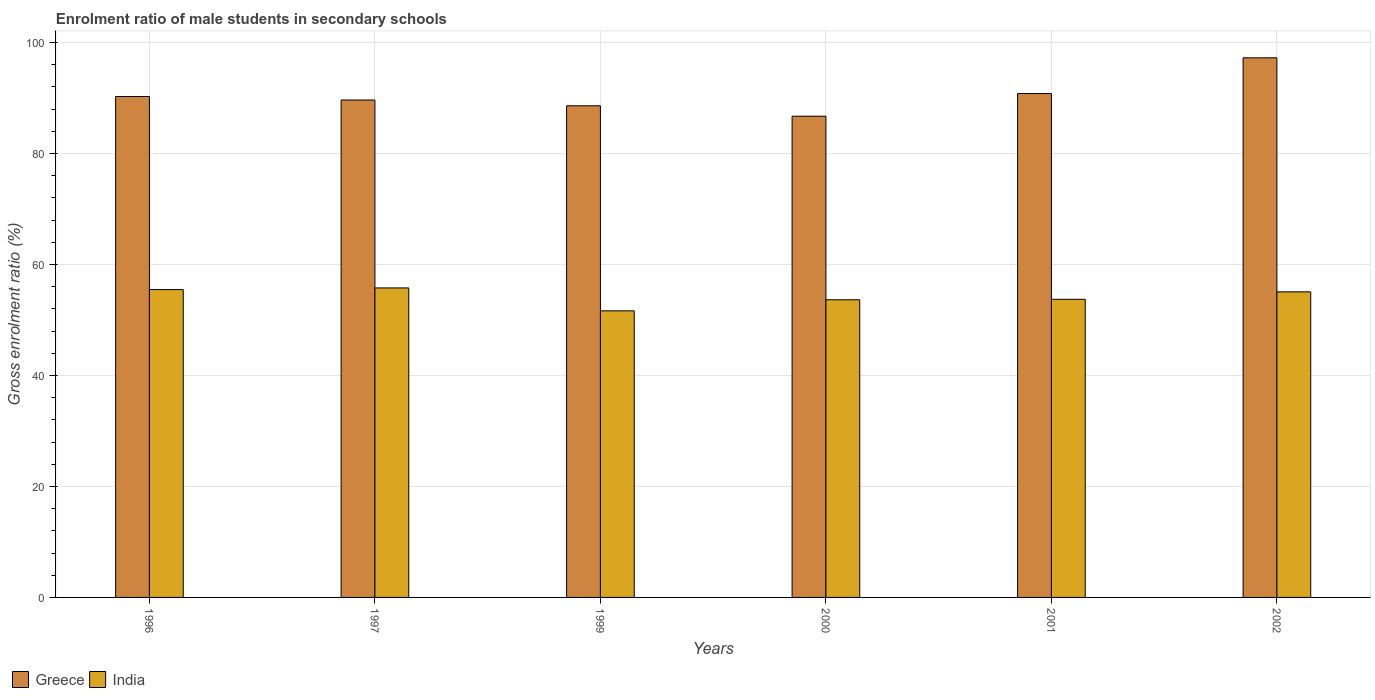How many groups of bars are there?
Make the answer very short. 6. Are the number of bars per tick equal to the number of legend labels?
Your answer should be very brief. Yes. How many bars are there on the 5th tick from the left?
Keep it short and to the point. 2. In how many cases, is the number of bars for a given year not equal to the number of legend labels?
Offer a terse response. 0. What is the enrolment ratio of male students in secondary schools in India in 1999?
Your response must be concise. 51.64. Across all years, what is the maximum enrolment ratio of male students in secondary schools in Greece?
Offer a very short reply. 97.24. Across all years, what is the minimum enrolment ratio of male students in secondary schools in India?
Provide a succinct answer. 51.64. In which year was the enrolment ratio of male students in secondary schools in India maximum?
Give a very brief answer. 1997. In which year was the enrolment ratio of male students in secondary schools in Greece minimum?
Offer a terse response. 2000. What is the total enrolment ratio of male students in secondary schools in India in the graph?
Give a very brief answer. 325.3. What is the difference between the enrolment ratio of male students in secondary schools in India in 1997 and that in 2002?
Offer a terse response. 0.71. What is the difference between the enrolment ratio of male students in secondary schools in India in 2001 and the enrolment ratio of male students in secondary schools in Greece in 2002?
Offer a terse response. -43.52. What is the average enrolment ratio of male students in secondary schools in India per year?
Offer a very short reply. 54.22. In the year 2000, what is the difference between the enrolment ratio of male students in secondary schools in Greece and enrolment ratio of male students in secondary schools in India?
Offer a very short reply. 33.08. In how many years, is the enrolment ratio of male students in secondary schools in Greece greater than 32 %?
Offer a very short reply. 6. What is the ratio of the enrolment ratio of male students in secondary schools in India in 1999 to that in 2001?
Your response must be concise. 0.96. Is the enrolment ratio of male students in secondary schools in Greece in 1996 less than that in 1999?
Your answer should be very brief. No. What is the difference between the highest and the second highest enrolment ratio of male students in secondary schools in Greece?
Provide a short and direct response. 6.44. What is the difference between the highest and the lowest enrolment ratio of male students in secondary schools in Greece?
Ensure brevity in your answer.  10.52. In how many years, is the enrolment ratio of male students in secondary schools in Greece greater than the average enrolment ratio of male students in secondary schools in Greece taken over all years?
Ensure brevity in your answer.  2. Is the sum of the enrolment ratio of male students in secondary schools in Greece in 1996 and 2002 greater than the maximum enrolment ratio of male students in secondary schools in India across all years?
Provide a succinct answer. Yes. How many bars are there?
Provide a succinct answer. 12. Are all the bars in the graph horizontal?
Offer a very short reply. No. How many years are there in the graph?
Offer a very short reply. 6. What is the difference between two consecutive major ticks on the Y-axis?
Offer a very short reply. 20. Are the values on the major ticks of Y-axis written in scientific E-notation?
Your answer should be very brief. No. Does the graph contain any zero values?
Give a very brief answer. No. What is the title of the graph?
Offer a very short reply. Enrolment ratio of male students in secondary schools. What is the label or title of the X-axis?
Provide a succinct answer. Years. What is the label or title of the Y-axis?
Your response must be concise. Gross enrolment ratio (%). What is the Gross enrolment ratio (%) of Greece in 1996?
Your response must be concise. 90.26. What is the Gross enrolment ratio (%) of India in 1996?
Give a very brief answer. 55.47. What is the Gross enrolment ratio (%) in Greece in 1997?
Give a very brief answer. 89.63. What is the Gross enrolment ratio (%) in India in 1997?
Ensure brevity in your answer.  55.77. What is the Gross enrolment ratio (%) in Greece in 1999?
Provide a short and direct response. 88.59. What is the Gross enrolment ratio (%) of India in 1999?
Keep it short and to the point. 51.64. What is the Gross enrolment ratio (%) of Greece in 2000?
Your answer should be very brief. 86.71. What is the Gross enrolment ratio (%) in India in 2000?
Keep it short and to the point. 53.64. What is the Gross enrolment ratio (%) of Greece in 2001?
Offer a very short reply. 90.8. What is the Gross enrolment ratio (%) in India in 2001?
Provide a short and direct response. 53.72. What is the Gross enrolment ratio (%) of Greece in 2002?
Your answer should be very brief. 97.24. What is the Gross enrolment ratio (%) of India in 2002?
Your response must be concise. 55.06. Across all years, what is the maximum Gross enrolment ratio (%) of Greece?
Offer a terse response. 97.24. Across all years, what is the maximum Gross enrolment ratio (%) of India?
Ensure brevity in your answer.  55.77. Across all years, what is the minimum Gross enrolment ratio (%) of Greece?
Your response must be concise. 86.71. Across all years, what is the minimum Gross enrolment ratio (%) of India?
Offer a very short reply. 51.64. What is the total Gross enrolment ratio (%) in Greece in the graph?
Your answer should be compact. 543.24. What is the total Gross enrolment ratio (%) in India in the graph?
Your answer should be very brief. 325.3. What is the difference between the Gross enrolment ratio (%) of Greece in 1996 and that in 1997?
Make the answer very short. 0.63. What is the difference between the Gross enrolment ratio (%) in India in 1996 and that in 1997?
Offer a terse response. -0.3. What is the difference between the Gross enrolment ratio (%) of Greece in 1996 and that in 1999?
Offer a terse response. 1.67. What is the difference between the Gross enrolment ratio (%) of India in 1996 and that in 1999?
Offer a very short reply. 3.83. What is the difference between the Gross enrolment ratio (%) in Greece in 1996 and that in 2000?
Your response must be concise. 3.55. What is the difference between the Gross enrolment ratio (%) of India in 1996 and that in 2000?
Your answer should be compact. 1.84. What is the difference between the Gross enrolment ratio (%) of Greece in 1996 and that in 2001?
Your answer should be compact. -0.54. What is the difference between the Gross enrolment ratio (%) of India in 1996 and that in 2001?
Make the answer very short. 1.75. What is the difference between the Gross enrolment ratio (%) of Greece in 1996 and that in 2002?
Make the answer very short. -6.97. What is the difference between the Gross enrolment ratio (%) of India in 1996 and that in 2002?
Provide a succinct answer. 0.41. What is the difference between the Gross enrolment ratio (%) of Greece in 1997 and that in 1999?
Keep it short and to the point. 1.04. What is the difference between the Gross enrolment ratio (%) of India in 1997 and that in 1999?
Your answer should be very brief. 4.13. What is the difference between the Gross enrolment ratio (%) in Greece in 1997 and that in 2000?
Keep it short and to the point. 2.92. What is the difference between the Gross enrolment ratio (%) of India in 1997 and that in 2000?
Provide a short and direct response. 2.13. What is the difference between the Gross enrolment ratio (%) in Greece in 1997 and that in 2001?
Your response must be concise. -1.17. What is the difference between the Gross enrolment ratio (%) in India in 1997 and that in 2001?
Your response must be concise. 2.05. What is the difference between the Gross enrolment ratio (%) in Greece in 1997 and that in 2002?
Provide a succinct answer. -7.61. What is the difference between the Gross enrolment ratio (%) of India in 1997 and that in 2002?
Make the answer very short. 0.71. What is the difference between the Gross enrolment ratio (%) of Greece in 1999 and that in 2000?
Keep it short and to the point. 1.88. What is the difference between the Gross enrolment ratio (%) of India in 1999 and that in 2000?
Your answer should be very brief. -2. What is the difference between the Gross enrolment ratio (%) of Greece in 1999 and that in 2001?
Make the answer very short. -2.21. What is the difference between the Gross enrolment ratio (%) of India in 1999 and that in 2001?
Provide a short and direct response. -2.08. What is the difference between the Gross enrolment ratio (%) of Greece in 1999 and that in 2002?
Provide a short and direct response. -8.65. What is the difference between the Gross enrolment ratio (%) of India in 1999 and that in 2002?
Ensure brevity in your answer.  -3.42. What is the difference between the Gross enrolment ratio (%) of Greece in 2000 and that in 2001?
Your answer should be very brief. -4.09. What is the difference between the Gross enrolment ratio (%) in India in 2000 and that in 2001?
Give a very brief answer. -0.08. What is the difference between the Gross enrolment ratio (%) in Greece in 2000 and that in 2002?
Your response must be concise. -10.52. What is the difference between the Gross enrolment ratio (%) in India in 2000 and that in 2002?
Ensure brevity in your answer.  -1.43. What is the difference between the Gross enrolment ratio (%) of Greece in 2001 and that in 2002?
Your answer should be very brief. -6.44. What is the difference between the Gross enrolment ratio (%) in India in 2001 and that in 2002?
Make the answer very short. -1.34. What is the difference between the Gross enrolment ratio (%) of Greece in 1996 and the Gross enrolment ratio (%) of India in 1997?
Ensure brevity in your answer.  34.49. What is the difference between the Gross enrolment ratio (%) in Greece in 1996 and the Gross enrolment ratio (%) in India in 1999?
Your answer should be compact. 38.63. What is the difference between the Gross enrolment ratio (%) in Greece in 1996 and the Gross enrolment ratio (%) in India in 2000?
Ensure brevity in your answer.  36.63. What is the difference between the Gross enrolment ratio (%) in Greece in 1996 and the Gross enrolment ratio (%) in India in 2001?
Your response must be concise. 36.54. What is the difference between the Gross enrolment ratio (%) in Greece in 1996 and the Gross enrolment ratio (%) in India in 2002?
Keep it short and to the point. 35.2. What is the difference between the Gross enrolment ratio (%) in Greece in 1997 and the Gross enrolment ratio (%) in India in 1999?
Provide a short and direct response. 37.99. What is the difference between the Gross enrolment ratio (%) of Greece in 1997 and the Gross enrolment ratio (%) of India in 2000?
Your answer should be compact. 36. What is the difference between the Gross enrolment ratio (%) in Greece in 1997 and the Gross enrolment ratio (%) in India in 2001?
Your response must be concise. 35.91. What is the difference between the Gross enrolment ratio (%) of Greece in 1997 and the Gross enrolment ratio (%) of India in 2002?
Provide a short and direct response. 34.57. What is the difference between the Gross enrolment ratio (%) in Greece in 1999 and the Gross enrolment ratio (%) in India in 2000?
Offer a terse response. 34.96. What is the difference between the Gross enrolment ratio (%) in Greece in 1999 and the Gross enrolment ratio (%) in India in 2001?
Provide a succinct answer. 34.87. What is the difference between the Gross enrolment ratio (%) of Greece in 1999 and the Gross enrolment ratio (%) of India in 2002?
Give a very brief answer. 33.53. What is the difference between the Gross enrolment ratio (%) in Greece in 2000 and the Gross enrolment ratio (%) in India in 2001?
Give a very brief answer. 32.99. What is the difference between the Gross enrolment ratio (%) of Greece in 2000 and the Gross enrolment ratio (%) of India in 2002?
Keep it short and to the point. 31.65. What is the difference between the Gross enrolment ratio (%) of Greece in 2001 and the Gross enrolment ratio (%) of India in 2002?
Give a very brief answer. 35.74. What is the average Gross enrolment ratio (%) of Greece per year?
Your response must be concise. 90.54. What is the average Gross enrolment ratio (%) in India per year?
Ensure brevity in your answer.  54.22. In the year 1996, what is the difference between the Gross enrolment ratio (%) in Greece and Gross enrolment ratio (%) in India?
Your response must be concise. 34.79. In the year 1997, what is the difference between the Gross enrolment ratio (%) in Greece and Gross enrolment ratio (%) in India?
Give a very brief answer. 33.86. In the year 1999, what is the difference between the Gross enrolment ratio (%) in Greece and Gross enrolment ratio (%) in India?
Your response must be concise. 36.95. In the year 2000, what is the difference between the Gross enrolment ratio (%) in Greece and Gross enrolment ratio (%) in India?
Make the answer very short. 33.08. In the year 2001, what is the difference between the Gross enrolment ratio (%) in Greece and Gross enrolment ratio (%) in India?
Offer a very short reply. 37.08. In the year 2002, what is the difference between the Gross enrolment ratio (%) in Greece and Gross enrolment ratio (%) in India?
Provide a short and direct response. 42.18. What is the ratio of the Gross enrolment ratio (%) in Greece in 1996 to that in 1997?
Provide a succinct answer. 1.01. What is the ratio of the Gross enrolment ratio (%) of Greece in 1996 to that in 1999?
Give a very brief answer. 1.02. What is the ratio of the Gross enrolment ratio (%) of India in 1996 to that in 1999?
Offer a very short reply. 1.07. What is the ratio of the Gross enrolment ratio (%) of Greece in 1996 to that in 2000?
Your answer should be compact. 1.04. What is the ratio of the Gross enrolment ratio (%) in India in 1996 to that in 2000?
Offer a very short reply. 1.03. What is the ratio of the Gross enrolment ratio (%) of Greece in 1996 to that in 2001?
Your answer should be compact. 0.99. What is the ratio of the Gross enrolment ratio (%) in India in 1996 to that in 2001?
Offer a very short reply. 1.03. What is the ratio of the Gross enrolment ratio (%) in Greece in 1996 to that in 2002?
Offer a very short reply. 0.93. What is the ratio of the Gross enrolment ratio (%) in India in 1996 to that in 2002?
Offer a very short reply. 1.01. What is the ratio of the Gross enrolment ratio (%) of Greece in 1997 to that in 1999?
Ensure brevity in your answer.  1.01. What is the ratio of the Gross enrolment ratio (%) of India in 1997 to that in 1999?
Your response must be concise. 1.08. What is the ratio of the Gross enrolment ratio (%) in Greece in 1997 to that in 2000?
Offer a very short reply. 1.03. What is the ratio of the Gross enrolment ratio (%) of India in 1997 to that in 2000?
Make the answer very short. 1.04. What is the ratio of the Gross enrolment ratio (%) of Greece in 1997 to that in 2001?
Provide a succinct answer. 0.99. What is the ratio of the Gross enrolment ratio (%) of India in 1997 to that in 2001?
Your answer should be compact. 1.04. What is the ratio of the Gross enrolment ratio (%) in Greece in 1997 to that in 2002?
Give a very brief answer. 0.92. What is the ratio of the Gross enrolment ratio (%) in India in 1997 to that in 2002?
Provide a succinct answer. 1.01. What is the ratio of the Gross enrolment ratio (%) of Greece in 1999 to that in 2000?
Provide a succinct answer. 1.02. What is the ratio of the Gross enrolment ratio (%) of India in 1999 to that in 2000?
Your response must be concise. 0.96. What is the ratio of the Gross enrolment ratio (%) of Greece in 1999 to that in 2001?
Your response must be concise. 0.98. What is the ratio of the Gross enrolment ratio (%) of India in 1999 to that in 2001?
Offer a terse response. 0.96. What is the ratio of the Gross enrolment ratio (%) in Greece in 1999 to that in 2002?
Provide a succinct answer. 0.91. What is the ratio of the Gross enrolment ratio (%) of India in 1999 to that in 2002?
Ensure brevity in your answer.  0.94. What is the ratio of the Gross enrolment ratio (%) in Greece in 2000 to that in 2001?
Your response must be concise. 0.95. What is the ratio of the Gross enrolment ratio (%) of Greece in 2000 to that in 2002?
Ensure brevity in your answer.  0.89. What is the ratio of the Gross enrolment ratio (%) in India in 2000 to that in 2002?
Offer a terse response. 0.97. What is the ratio of the Gross enrolment ratio (%) in Greece in 2001 to that in 2002?
Offer a terse response. 0.93. What is the ratio of the Gross enrolment ratio (%) in India in 2001 to that in 2002?
Your answer should be very brief. 0.98. What is the difference between the highest and the second highest Gross enrolment ratio (%) of Greece?
Your answer should be very brief. 6.44. What is the difference between the highest and the second highest Gross enrolment ratio (%) in India?
Offer a terse response. 0.3. What is the difference between the highest and the lowest Gross enrolment ratio (%) of Greece?
Make the answer very short. 10.52. What is the difference between the highest and the lowest Gross enrolment ratio (%) in India?
Provide a short and direct response. 4.13. 